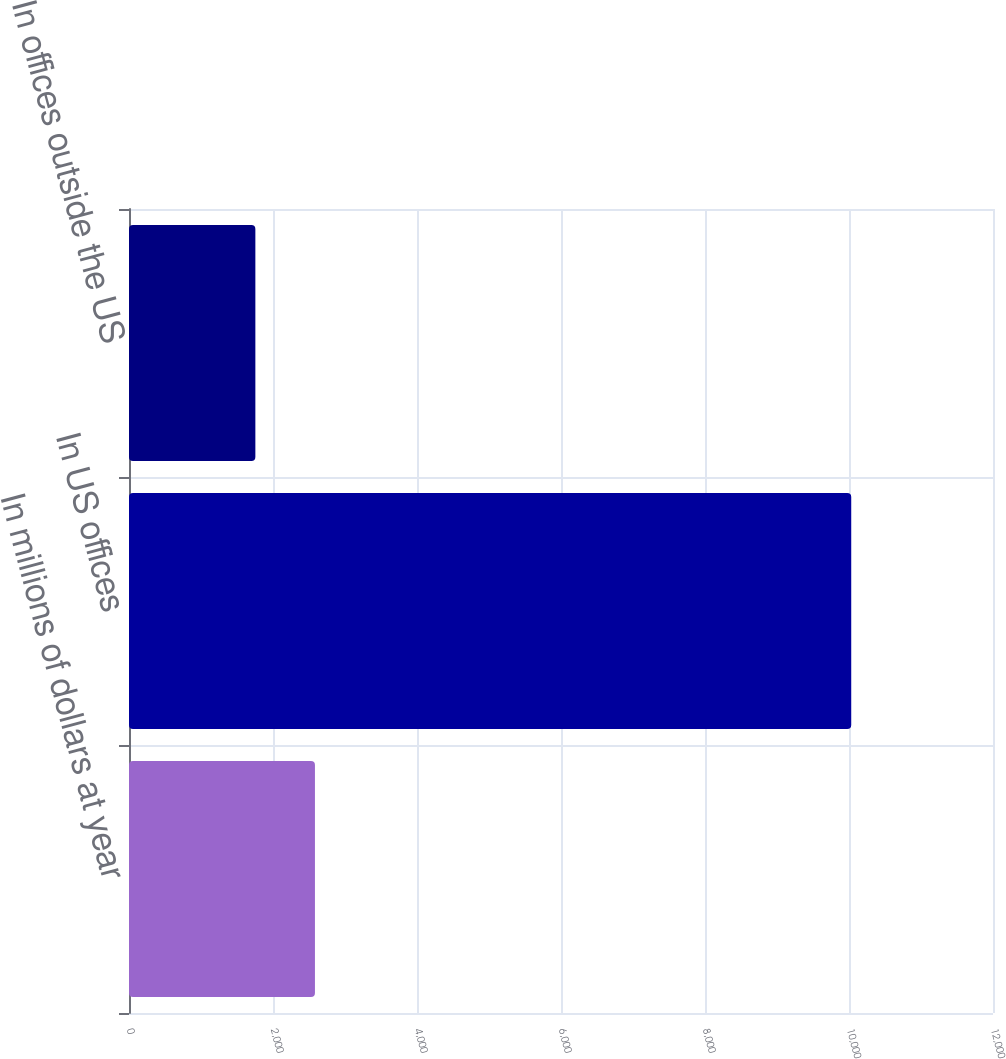<chart> <loc_0><loc_0><loc_500><loc_500><bar_chart><fcel>In millions of dollars at year<fcel>In US offices<fcel>In offices outside the US<nl><fcel>2582.6<fcel>10031<fcel>1755<nl></chart> 